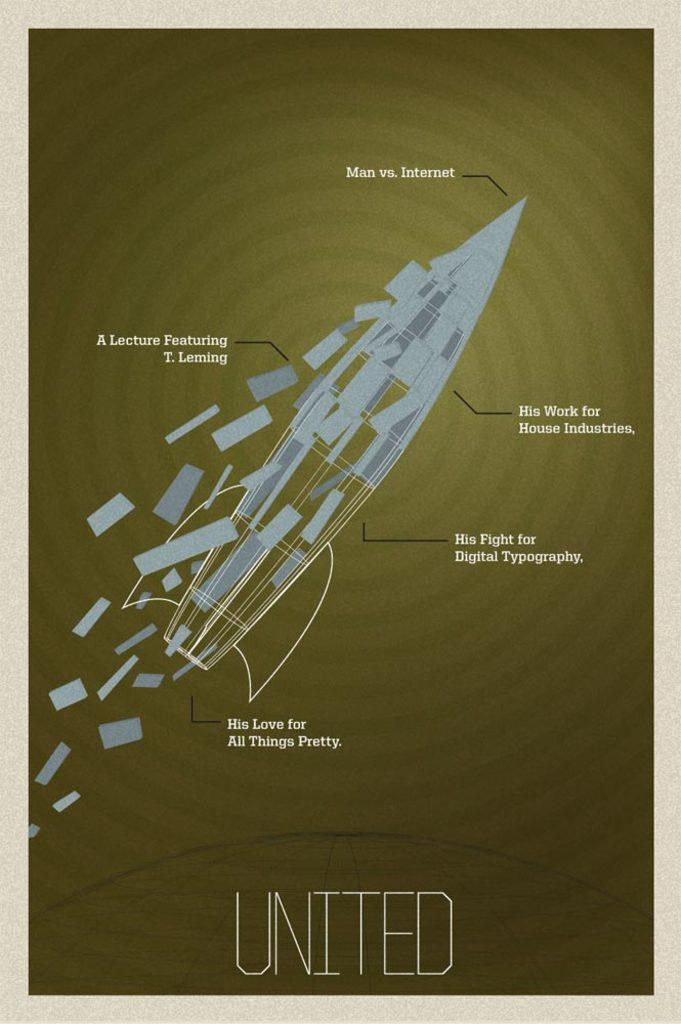Provide a one-sentence caption for the provided image. A poster for a lecture featuring T. Lemming. 